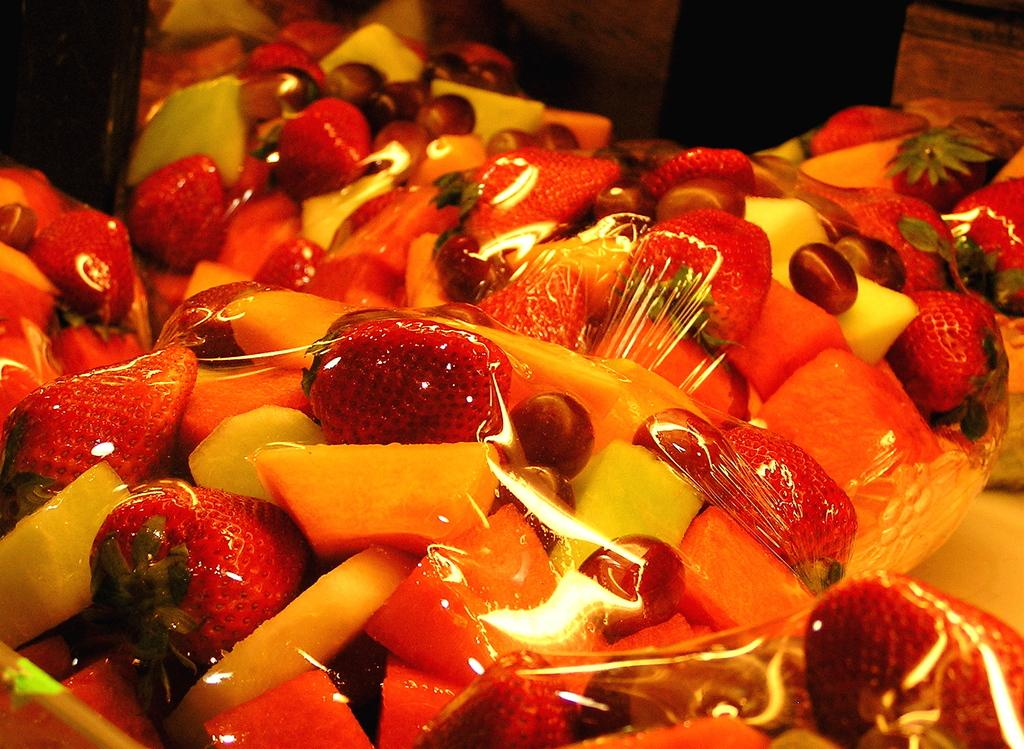What type of fruit can be seen in the image? There are grapes, musk melon, papaya, and strawberries in the image. Are there any other fruits present in the image besides the ones mentioned? No, the provided facts only mention grapes, musk melon, papaya, and strawberries. How are the fruits in the image presented? The fruits are covered in a wrapper. What is the son doing with the pear in the image? There is no son or pear present in the image; it only features grapes, musk melon, papaya, and strawberries covered in a wrapper. 